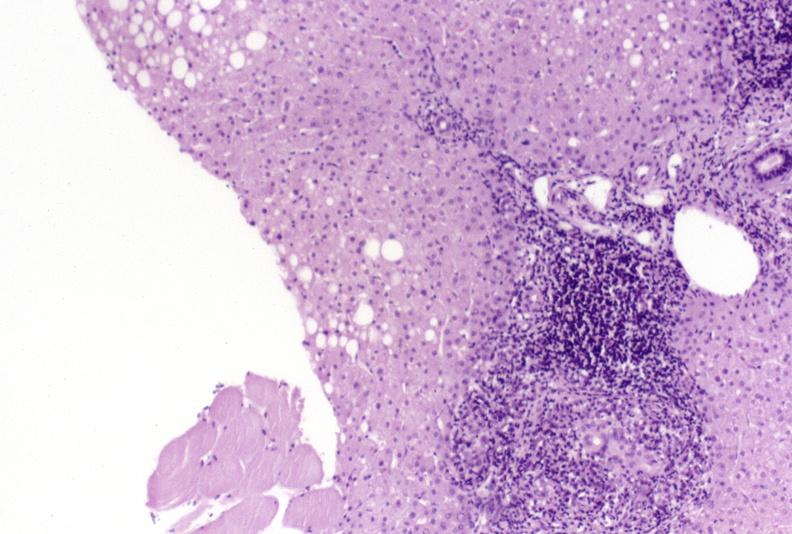s chronic lymphocytic leukemia present?
Answer the question using a single word or phrase. No 